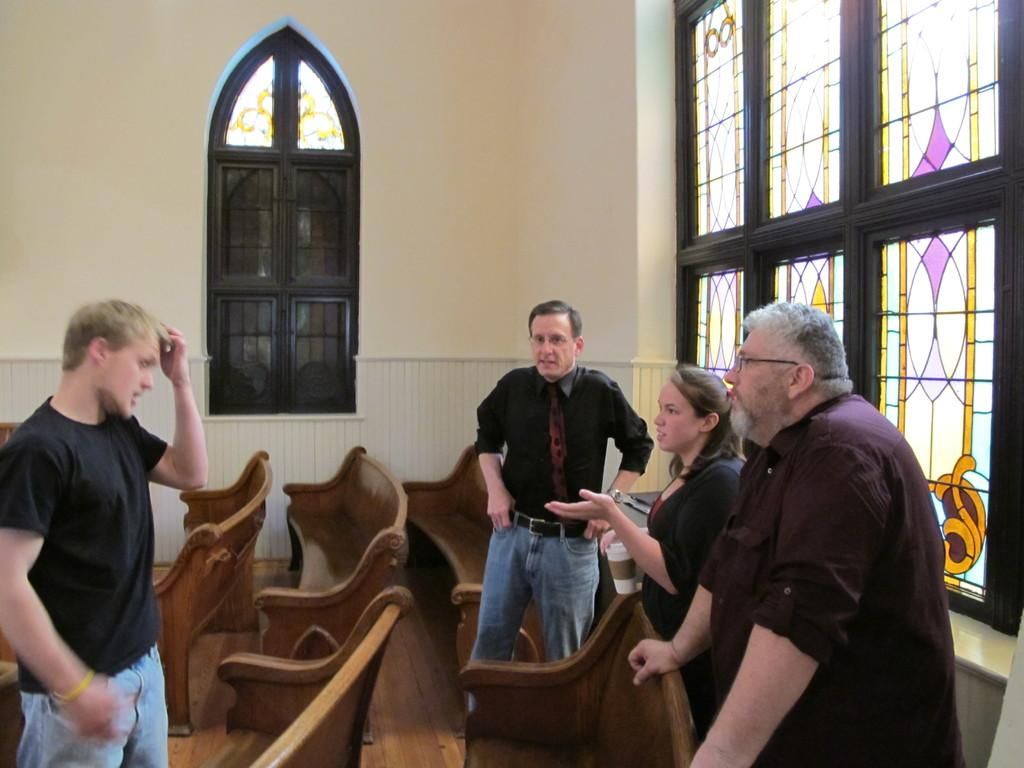How many people are present in the image? There are four persons standing in the image. What is located beside the persons? There are benches beside the persons. What can be seen behind the persons? There is a wall behind the persons. What feature is present on the wall? There are windows on the wall. What type of star can be seen shining brightly in the image? There is no star visible in the image; it is focused on the four persons, benches, wall, and windows. 